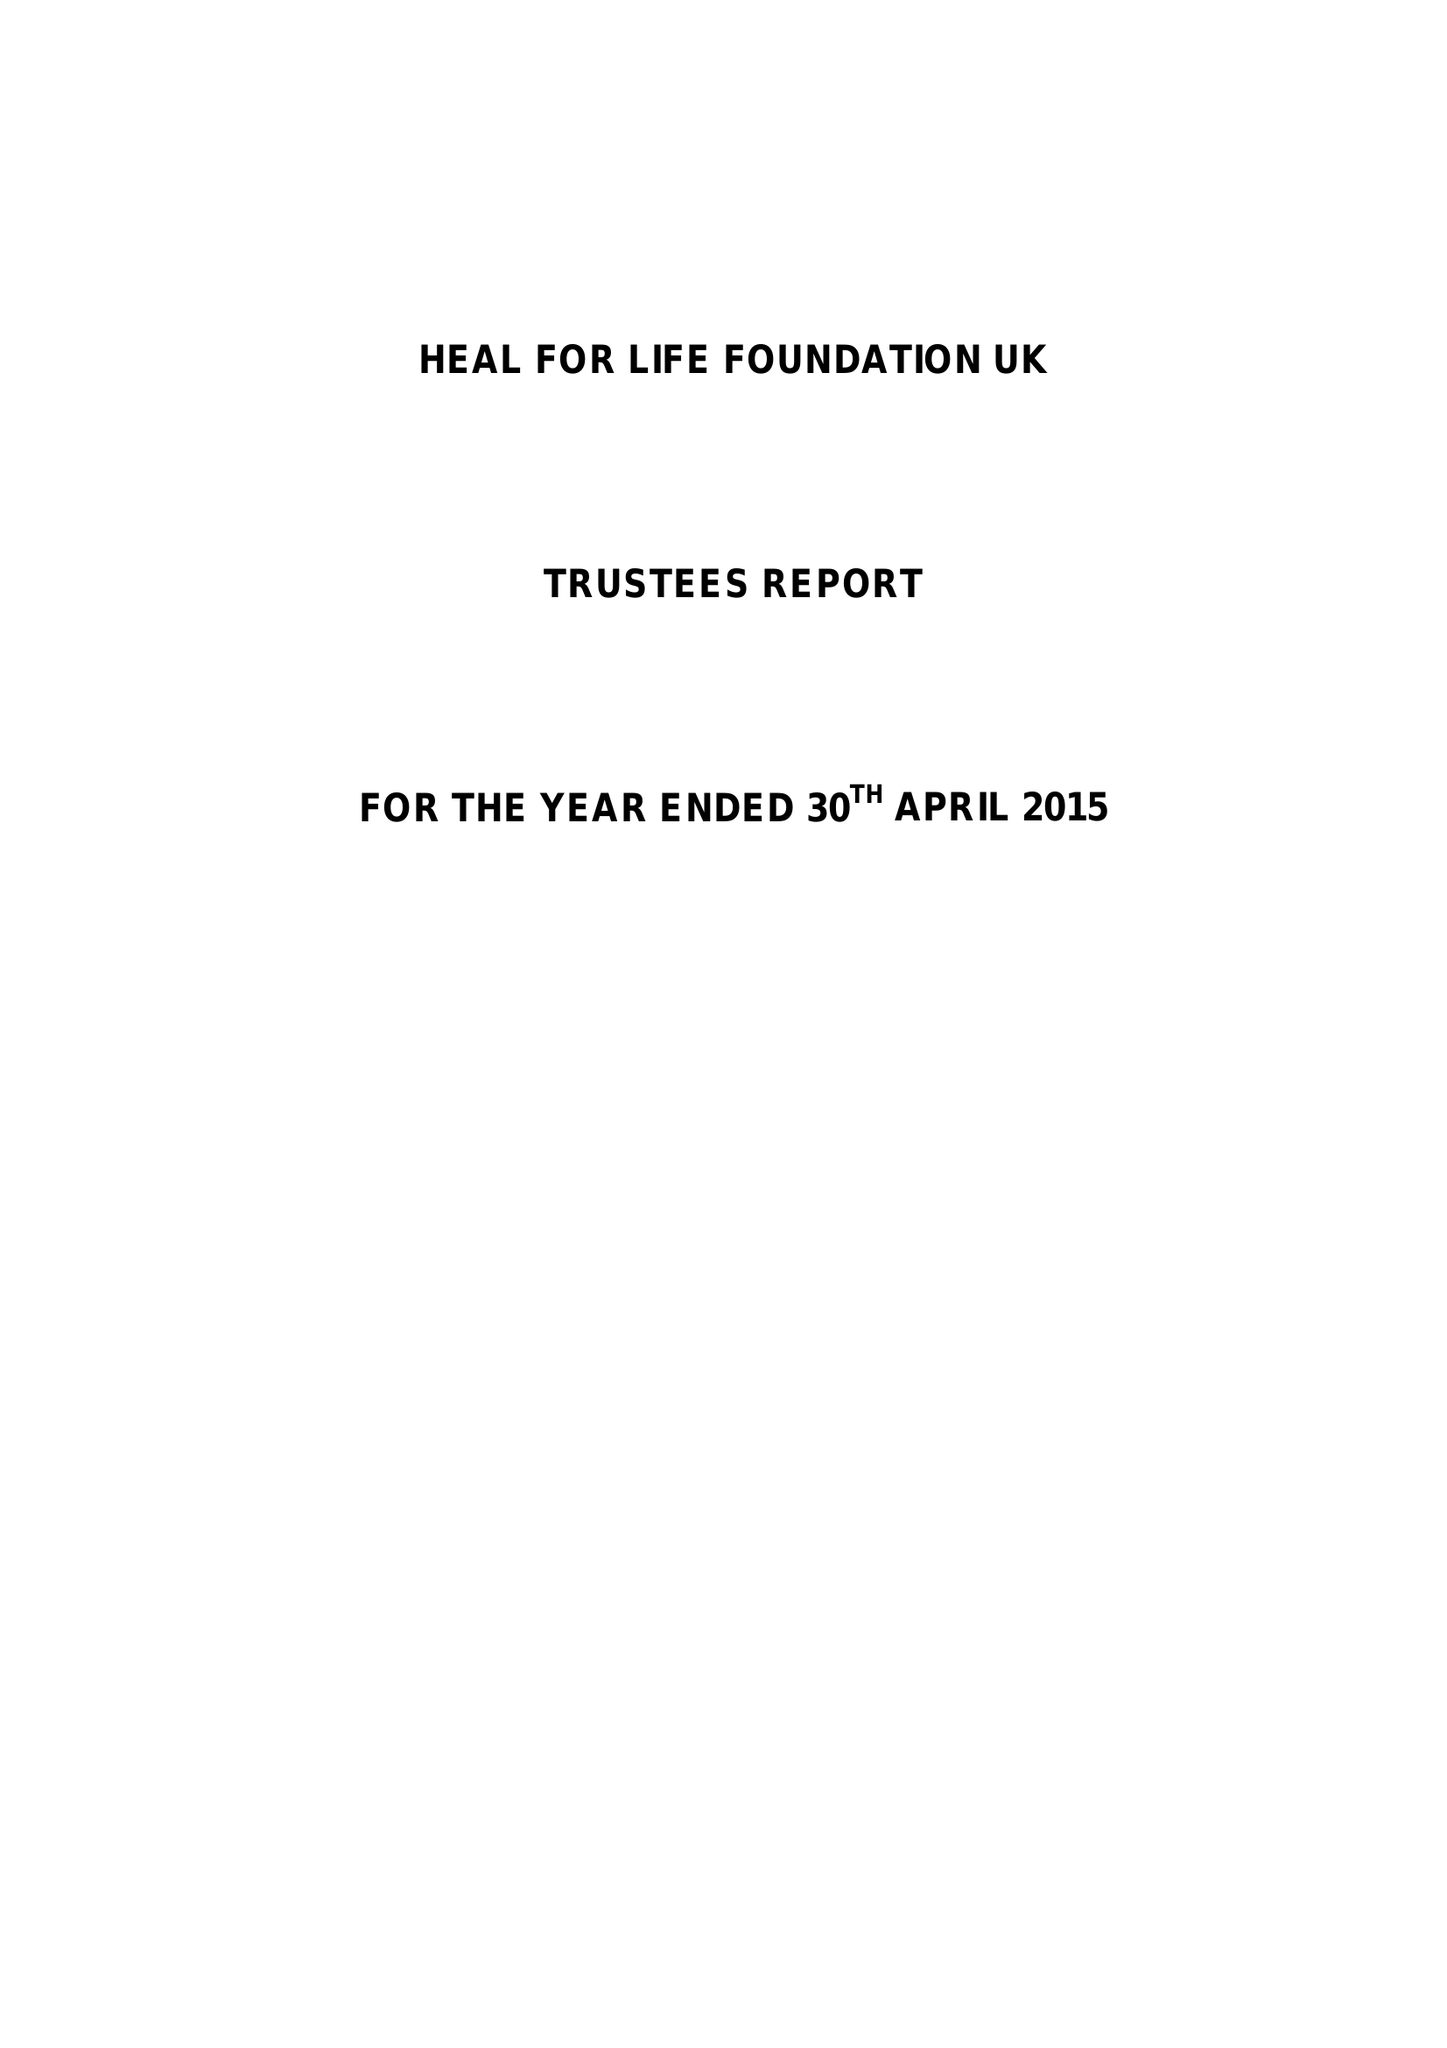What is the value for the income_annually_in_british_pounds?
Answer the question using a single word or phrase. 12438.00 